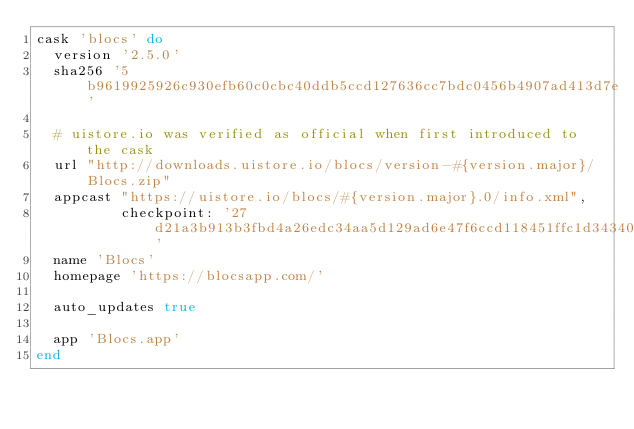Convert code to text. <code><loc_0><loc_0><loc_500><loc_500><_Ruby_>cask 'blocs' do
  version '2.5.0'
  sha256 '5b9619925926c930efb60c0cbc40ddb5ccd127636cc7bdc0456b4907ad413d7e'

  # uistore.io was verified as official when first introduced to the cask
  url "http://downloads.uistore.io/blocs/version-#{version.major}/Blocs.zip"
  appcast "https://uistore.io/blocs/#{version.major}.0/info.xml",
          checkpoint: '27d21a3b913b3fbd4a26edc34aa5d129ad6e47f6ccd118451ffc1d34340ade1d'
  name 'Blocs'
  homepage 'https://blocsapp.com/'

  auto_updates true

  app 'Blocs.app'
end
</code> 